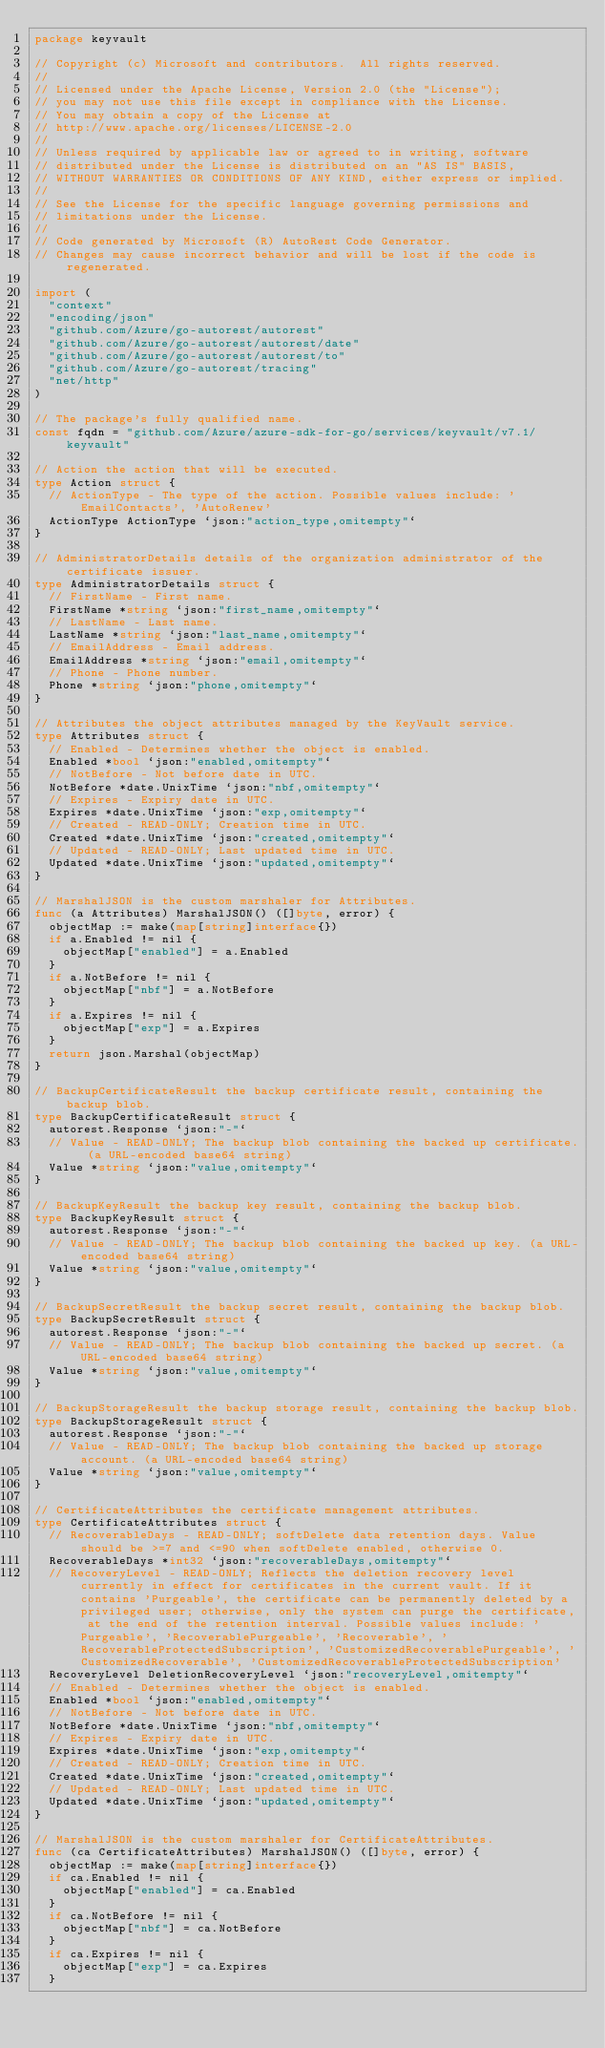<code> <loc_0><loc_0><loc_500><loc_500><_Go_>package keyvault

// Copyright (c) Microsoft and contributors.  All rights reserved.
//
// Licensed under the Apache License, Version 2.0 (the "License");
// you may not use this file except in compliance with the License.
// You may obtain a copy of the License at
// http://www.apache.org/licenses/LICENSE-2.0
//
// Unless required by applicable law or agreed to in writing, software
// distributed under the License is distributed on an "AS IS" BASIS,
// WITHOUT WARRANTIES OR CONDITIONS OF ANY KIND, either express or implied.
//
// See the License for the specific language governing permissions and
// limitations under the License.
//
// Code generated by Microsoft (R) AutoRest Code Generator.
// Changes may cause incorrect behavior and will be lost if the code is regenerated.

import (
	"context"
	"encoding/json"
	"github.com/Azure/go-autorest/autorest"
	"github.com/Azure/go-autorest/autorest/date"
	"github.com/Azure/go-autorest/autorest/to"
	"github.com/Azure/go-autorest/tracing"
	"net/http"
)

// The package's fully qualified name.
const fqdn = "github.com/Azure/azure-sdk-for-go/services/keyvault/v7.1/keyvault"

// Action the action that will be executed.
type Action struct {
	// ActionType - The type of the action. Possible values include: 'EmailContacts', 'AutoRenew'
	ActionType ActionType `json:"action_type,omitempty"`
}

// AdministratorDetails details of the organization administrator of the certificate issuer.
type AdministratorDetails struct {
	// FirstName - First name.
	FirstName *string `json:"first_name,omitempty"`
	// LastName - Last name.
	LastName *string `json:"last_name,omitempty"`
	// EmailAddress - Email address.
	EmailAddress *string `json:"email,omitempty"`
	// Phone - Phone number.
	Phone *string `json:"phone,omitempty"`
}

// Attributes the object attributes managed by the KeyVault service.
type Attributes struct {
	// Enabled - Determines whether the object is enabled.
	Enabled *bool `json:"enabled,omitempty"`
	// NotBefore - Not before date in UTC.
	NotBefore *date.UnixTime `json:"nbf,omitempty"`
	// Expires - Expiry date in UTC.
	Expires *date.UnixTime `json:"exp,omitempty"`
	// Created - READ-ONLY; Creation time in UTC.
	Created *date.UnixTime `json:"created,omitempty"`
	// Updated - READ-ONLY; Last updated time in UTC.
	Updated *date.UnixTime `json:"updated,omitempty"`
}

// MarshalJSON is the custom marshaler for Attributes.
func (a Attributes) MarshalJSON() ([]byte, error) {
	objectMap := make(map[string]interface{})
	if a.Enabled != nil {
		objectMap["enabled"] = a.Enabled
	}
	if a.NotBefore != nil {
		objectMap["nbf"] = a.NotBefore
	}
	if a.Expires != nil {
		objectMap["exp"] = a.Expires
	}
	return json.Marshal(objectMap)
}

// BackupCertificateResult the backup certificate result, containing the backup blob.
type BackupCertificateResult struct {
	autorest.Response `json:"-"`
	// Value - READ-ONLY; The backup blob containing the backed up certificate. (a URL-encoded base64 string)
	Value *string `json:"value,omitempty"`
}

// BackupKeyResult the backup key result, containing the backup blob.
type BackupKeyResult struct {
	autorest.Response `json:"-"`
	// Value - READ-ONLY; The backup blob containing the backed up key. (a URL-encoded base64 string)
	Value *string `json:"value,omitempty"`
}

// BackupSecretResult the backup secret result, containing the backup blob.
type BackupSecretResult struct {
	autorest.Response `json:"-"`
	// Value - READ-ONLY; The backup blob containing the backed up secret. (a URL-encoded base64 string)
	Value *string `json:"value,omitempty"`
}

// BackupStorageResult the backup storage result, containing the backup blob.
type BackupStorageResult struct {
	autorest.Response `json:"-"`
	// Value - READ-ONLY; The backup blob containing the backed up storage account. (a URL-encoded base64 string)
	Value *string `json:"value,omitempty"`
}

// CertificateAttributes the certificate management attributes.
type CertificateAttributes struct {
	// RecoverableDays - READ-ONLY; softDelete data retention days. Value should be >=7 and <=90 when softDelete enabled, otherwise 0.
	RecoverableDays *int32 `json:"recoverableDays,omitempty"`
	// RecoveryLevel - READ-ONLY; Reflects the deletion recovery level currently in effect for certificates in the current vault. If it contains 'Purgeable', the certificate can be permanently deleted by a privileged user; otherwise, only the system can purge the certificate, at the end of the retention interval. Possible values include: 'Purgeable', 'RecoverablePurgeable', 'Recoverable', 'RecoverableProtectedSubscription', 'CustomizedRecoverablePurgeable', 'CustomizedRecoverable', 'CustomizedRecoverableProtectedSubscription'
	RecoveryLevel DeletionRecoveryLevel `json:"recoveryLevel,omitempty"`
	// Enabled - Determines whether the object is enabled.
	Enabled *bool `json:"enabled,omitempty"`
	// NotBefore - Not before date in UTC.
	NotBefore *date.UnixTime `json:"nbf,omitempty"`
	// Expires - Expiry date in UTC.
	Expires *date.UnixTime `json:"exp,omitempty"`
	// Created - READ-ONLY; Creation time in UTC.
	Created *date.UnixTime `json:"created,omitempty"`
	// Updated - READ-ONLY; Last updated time in UTC.
	Updated *date.UnixTime `json:"updated,omitempty"`
}

// MarshalJSON is the custom marshaler for CertificateAttributes.
func (ca CertificateAttributes) MarshalJSON() ([]byte, error) {
	objectMap := make(map[string]interface{})
	if ca.Enabled != nil {
		objectMap["enabled"] = ca.Enabled
	}
	if ca.NotBefore != nil {
		objectMap["nbf"] = ca.NotBefore
	}
	if ca.Expires != nil {
		objectMap["exp"] = ca.Expires
	}</code> 